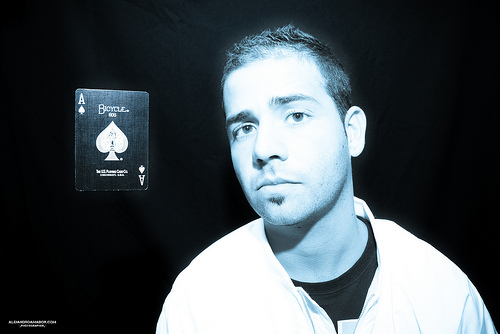<image>
Is there a black woman next to the painting? No. The black woman is not positioned next to the painting. They are located in different areas of the scene. 